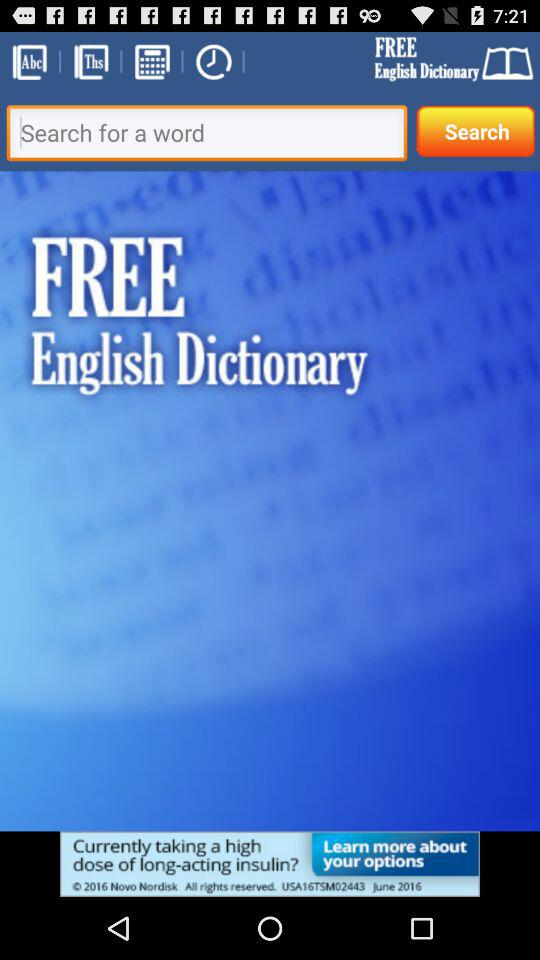What is the app name? The app name is "FREE English Dictionary". 